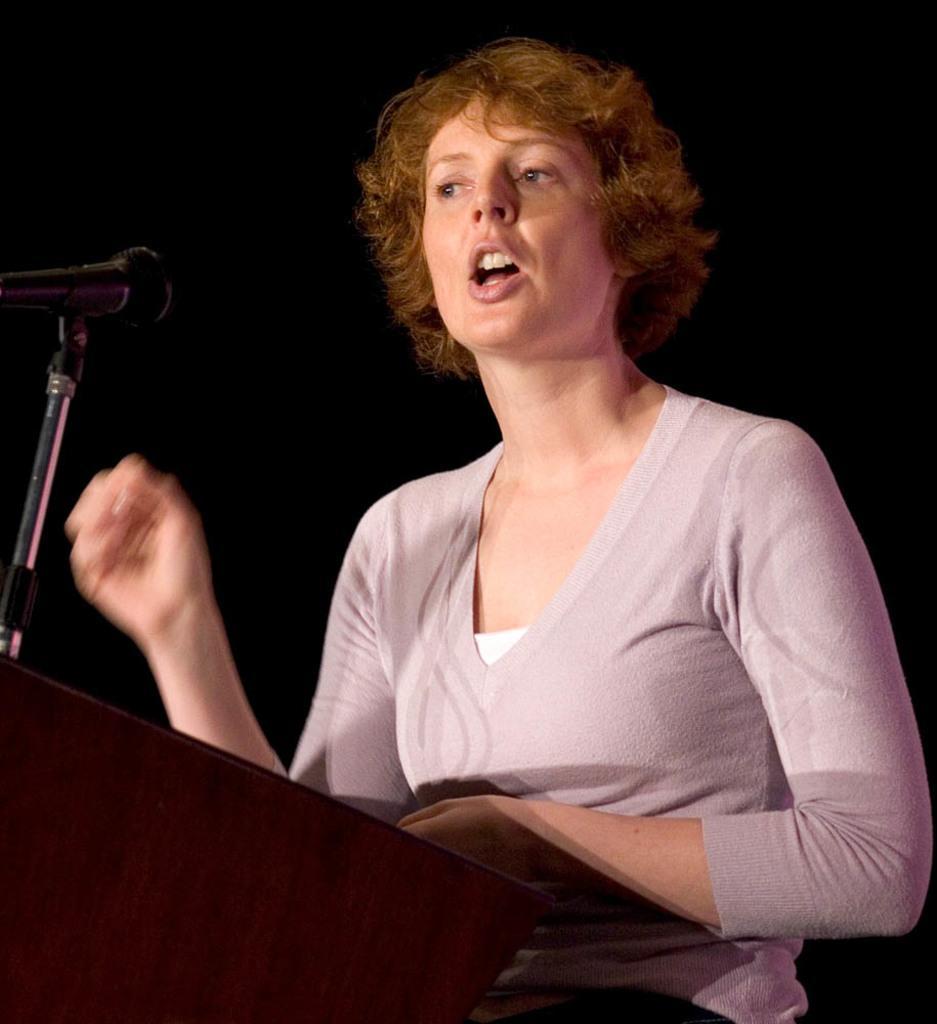Please provide a concise description of this image. In this image there is a person standing in front of the dais. On top of the days there is a mike. 